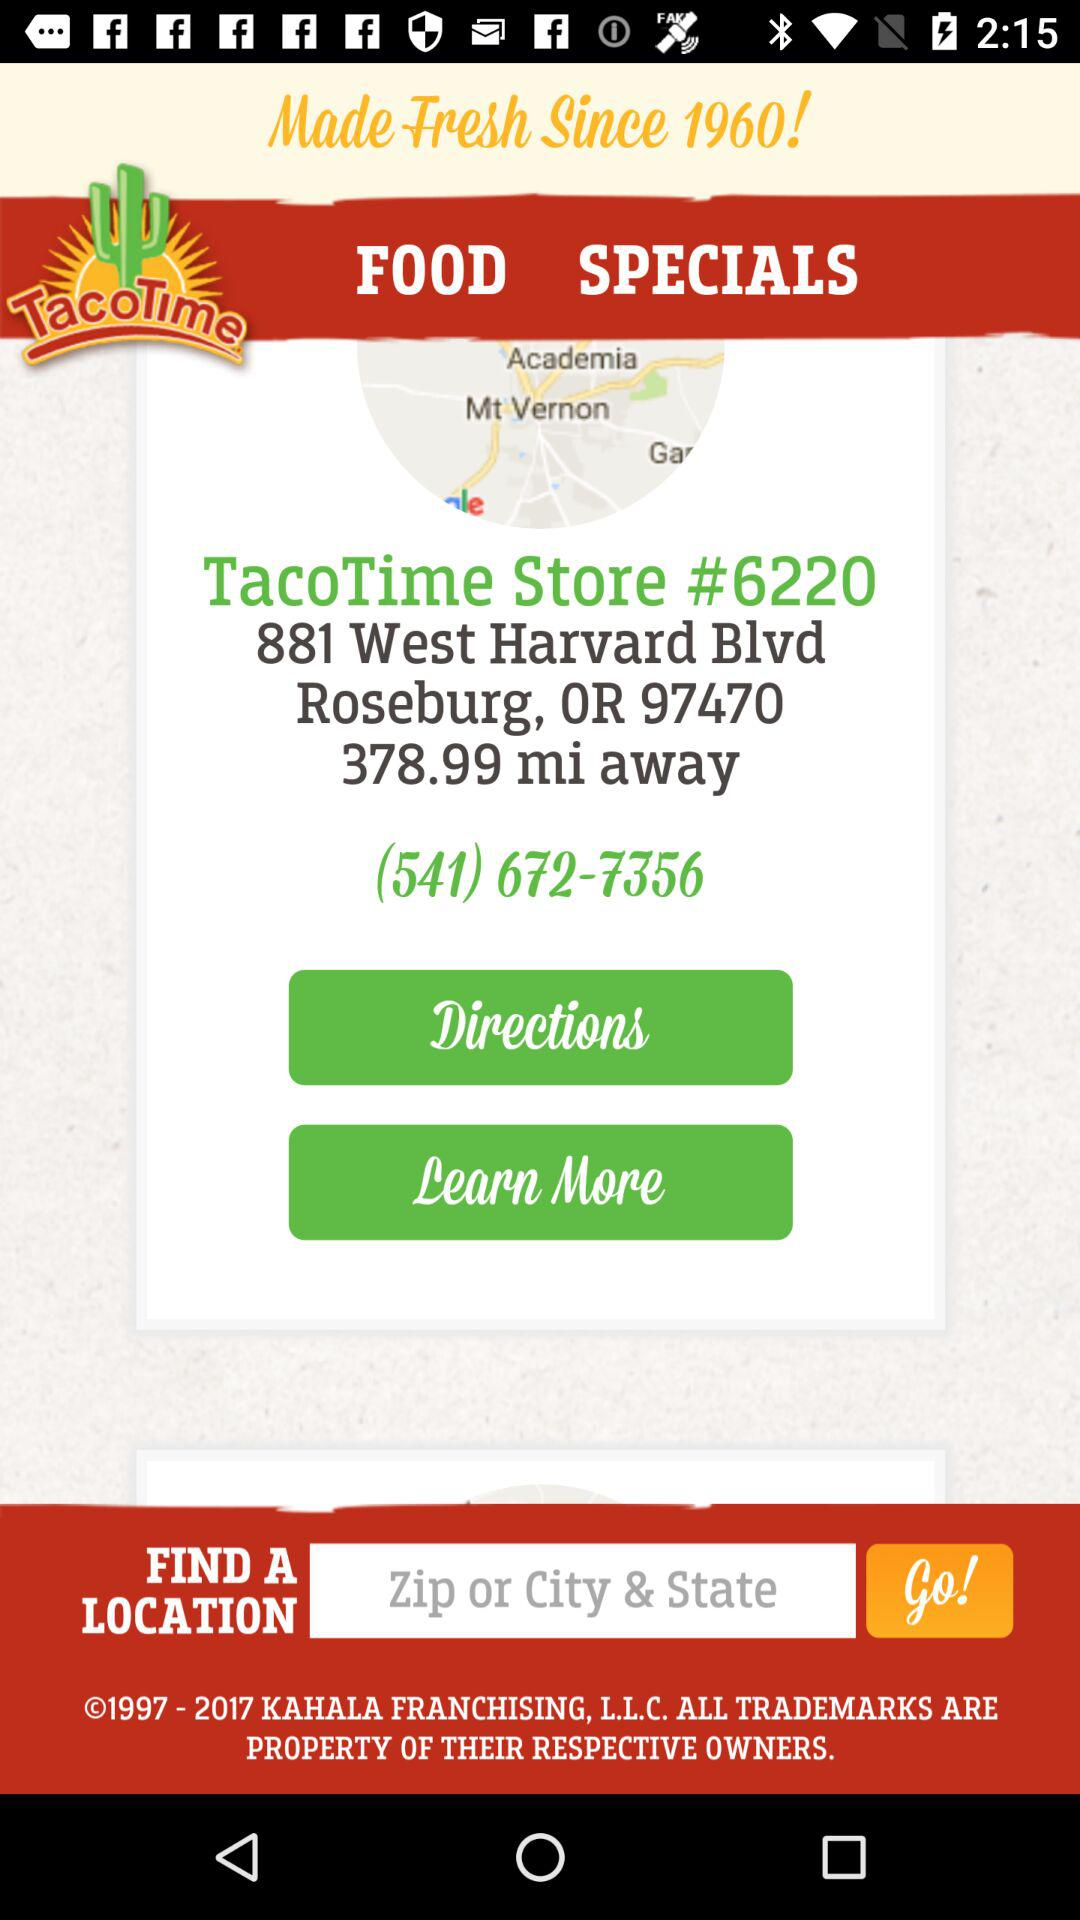How many miles away is the store?
Answer the question using a single word or phrase. 378.99 